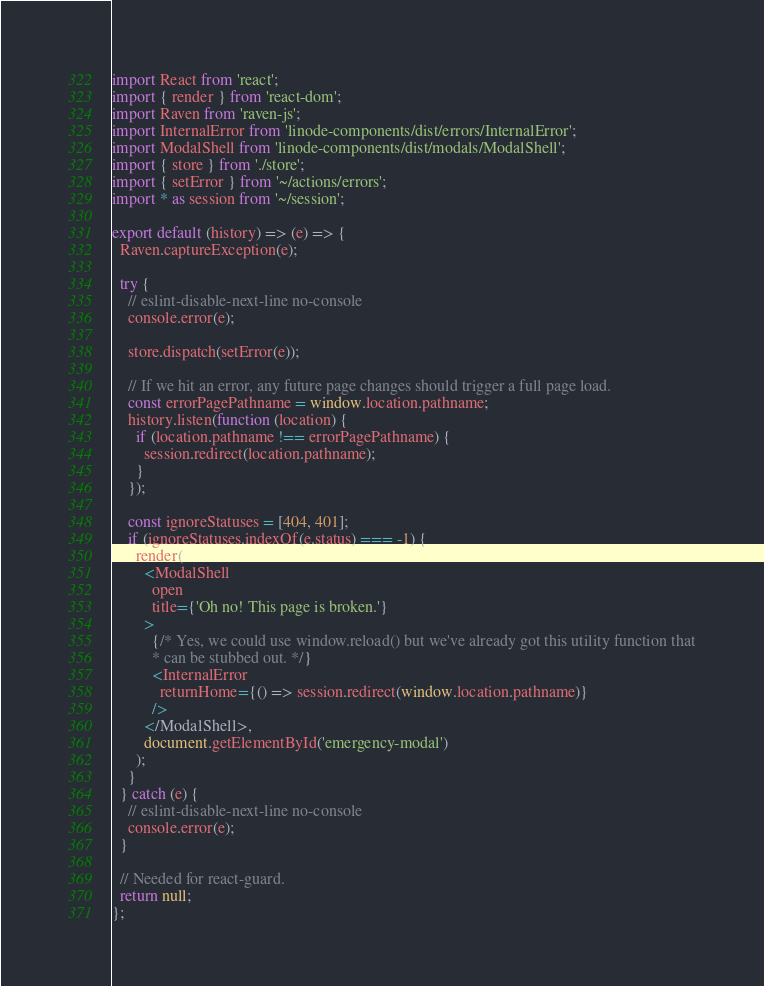<code> <loc_0><loc_0><loc_500><loc_500><_JavaScript_>import React from 'react';
import { render } from 'react-dom';
import Raven from 'raven-js';
import InternalError from 'linode-components/dist/errors/InternalError';
import ModalShell from 'linode-components/dist/modals/ModalShell';
import { store } from './store';
import { setError } from '~/actions/errors';
import * as session from '~/session';

export default (history) => (e) => {
  Raven.captureException(e);

  try {
    // eslint-disable-next-line no-console
    console.error(e);

    store.dispatch(setError(e));

    // If we hit an error, any future page changes should trigger a full page load.
    const errorPagePathname = window.location.pathname;
    history.listen(function (location) {
      if (location.pathname !== errorPagePathname) {
        session.redirect(location.pathname);
      }
    });

    const ignoreStatuses = [404, 401];
    if (ignoreStatuses.indexOf(e.status) === -1) {
      render(
        <ModalShell
          open
          title={'Oh no! This page is broken.'}
        >
          {/* Yes, we could use window.reload() but we've already got this utility function that
          * can be stubbed out. */}
          <InternalError
            returnHome={() => session.redirect(window.location.pathname)}
          />
        </ModalShell>,
        document.getElementById('emergency-modal')
      );
    }
  } catch (e) {
    // eslint-disable-next-line no-console
    console.error(e);
  }

  // Needed for react-guard.
  return null;
};
</code> 